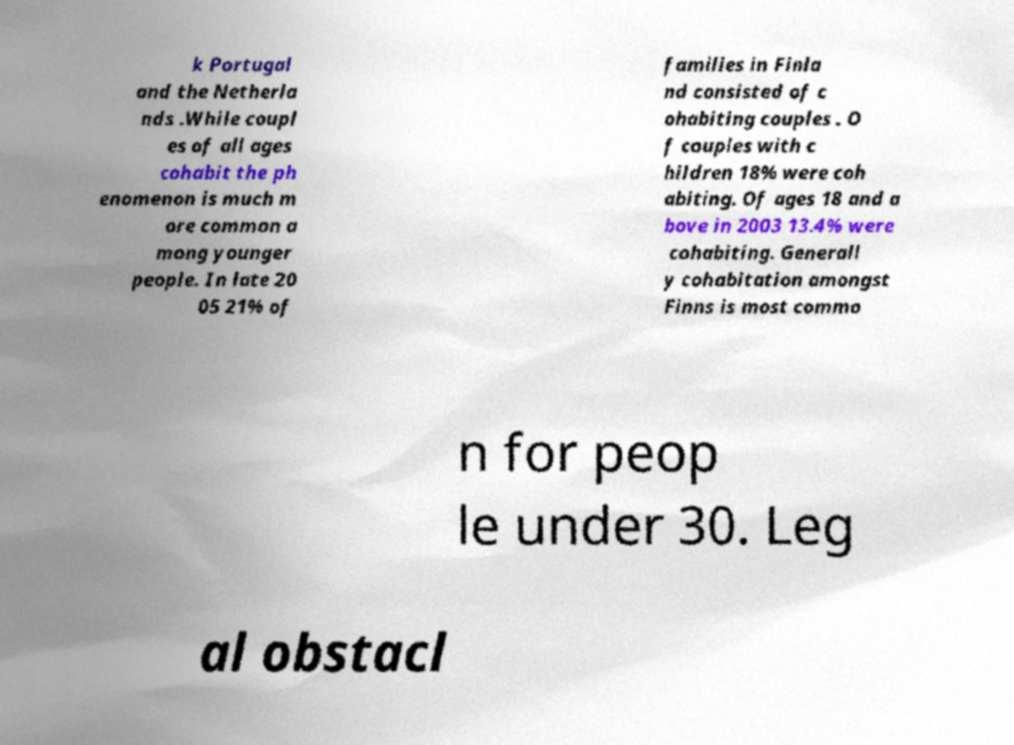What messages or text are displayed in this image? I need them in a readable, typed format. k Portugal and the Netherla nds .While coupl es of all ages cohabit the ph enomenon is much m ore common a mong younger people. In late 20 05 21% of families in Finla nd consisted of c ohabiting couples . O f couples with c hildren 18% were coh abiting. Of ages 18 and a bove in 2003 13.4% were cohabiting. Generall y cohabitation amongst Finns is most commo n for peop le under 30. Leg al obstacl 